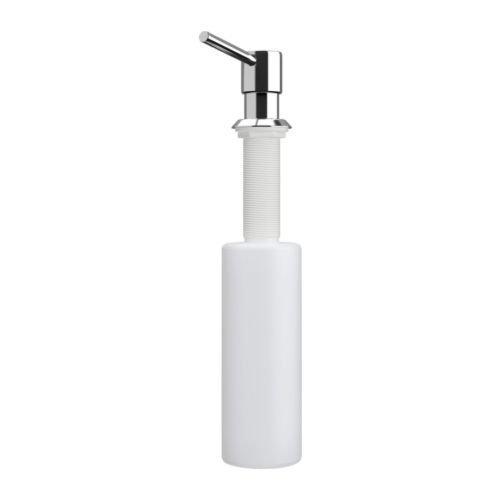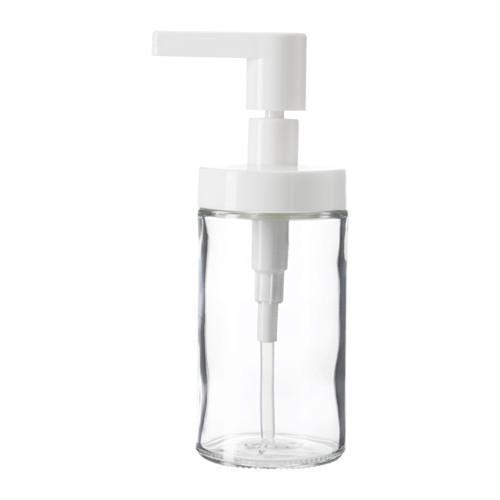The first image is the image on the left, the second image is the image on the right. Analyze the images presented: Is the assertion "Each image includes at least one clear glass cylinder with a white pump top, but the pump nozzles in the left and right images face opposite directions." valid? Answer yes or no. No. The first image is the image on the left, the second image is the image on the right. Analyze the images presented: Is the assertion "There are exactly two dispensers." valid? Answer yes or no. Yes. 